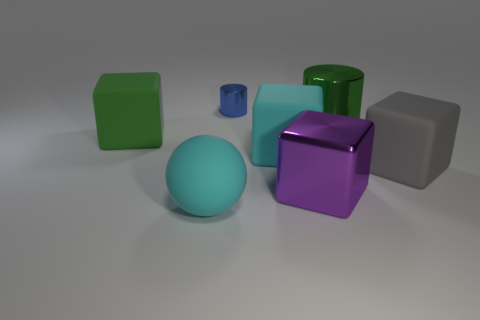What is the size of the cyan rubber object left of the metallic object behind the green shiny thing?
Your answer should be compact. Large. There is a green cube that is the same size as the ball; what is its material?
Provide a succinct answer. Rubber. What number of other things are the same size as the purple thing?
Your answer should be compact. 5. How many balls are either blue metal objects or red shiny objects?
Provide a short and direct response. 0. There is a sphere that is right of the green thing to the left of the rubber thing that is in front of the gray matte cube; what is it made of?
Give a very brief answer. Rubber. There is a cube that is the same color as the big ball; what is its material?
Make the answer very short. Rubber. How many cyan balls have the same material as the small blue object?
Make the answer very short. 0. Does the rubber cube that is behind the cyan block have the same size as the blue object?
Keep it short and to the point. No. What is the color of the ball that is made of the same material as the big gray cube?
Keep it short and to the point. Cyan. Are there any other things that have the same size as the blue metal cylinder?
Your response must be concise. No. 